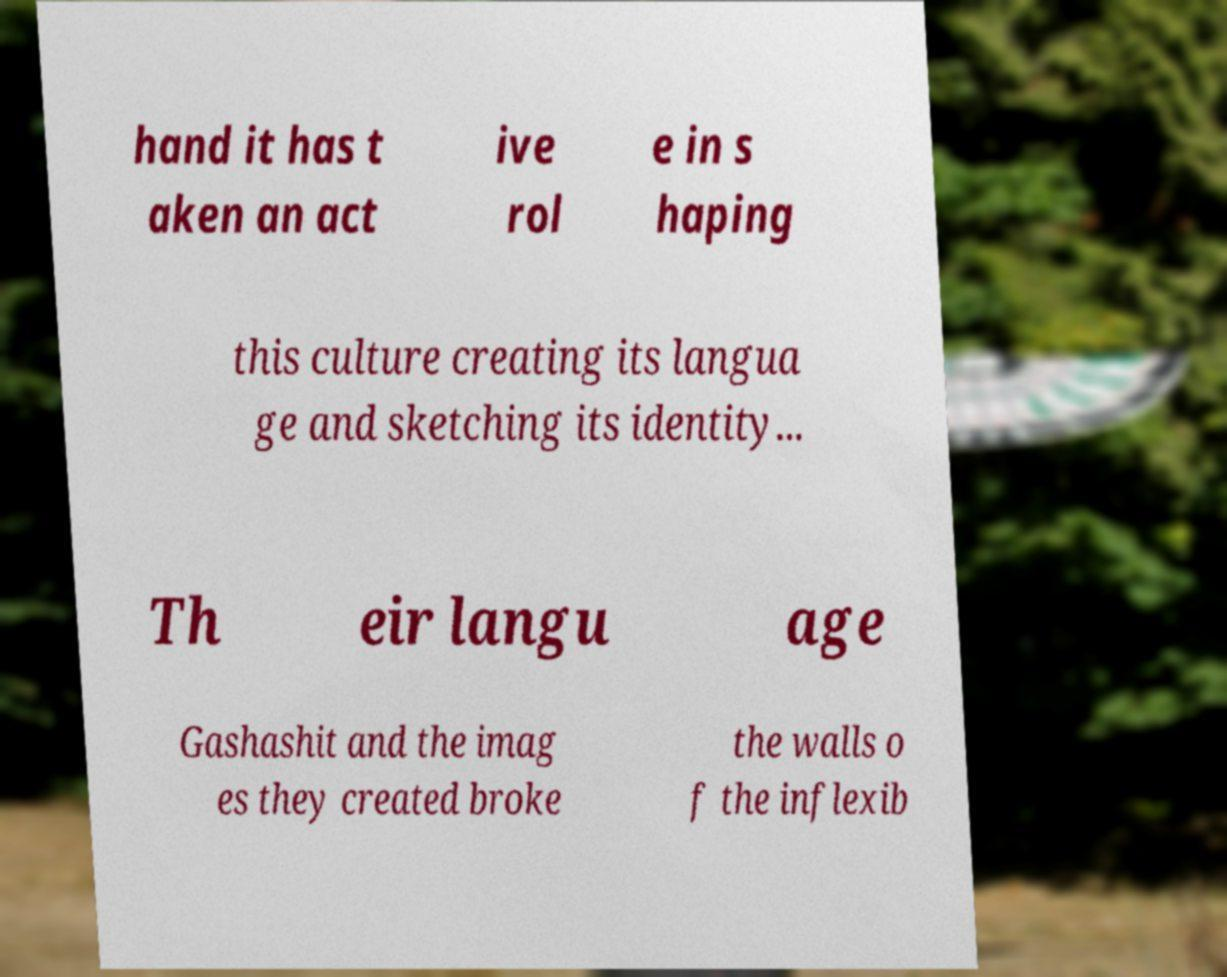I need the written content from this picture converted into text. Can you do that? hand it has t aken an act ive rol e in s haping this culture creating its langua ge and sketching its identity... Th eir langu age Gashashit and the imag es they created broke the walls o f the inflexib 